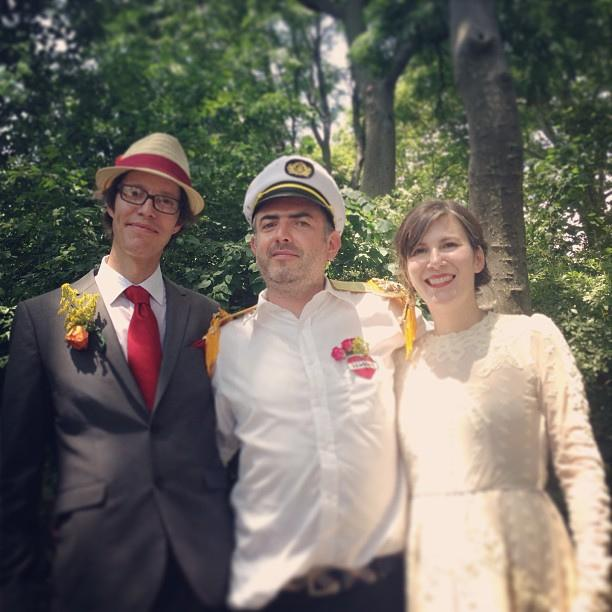What type of hat does the man in white have on? captain 